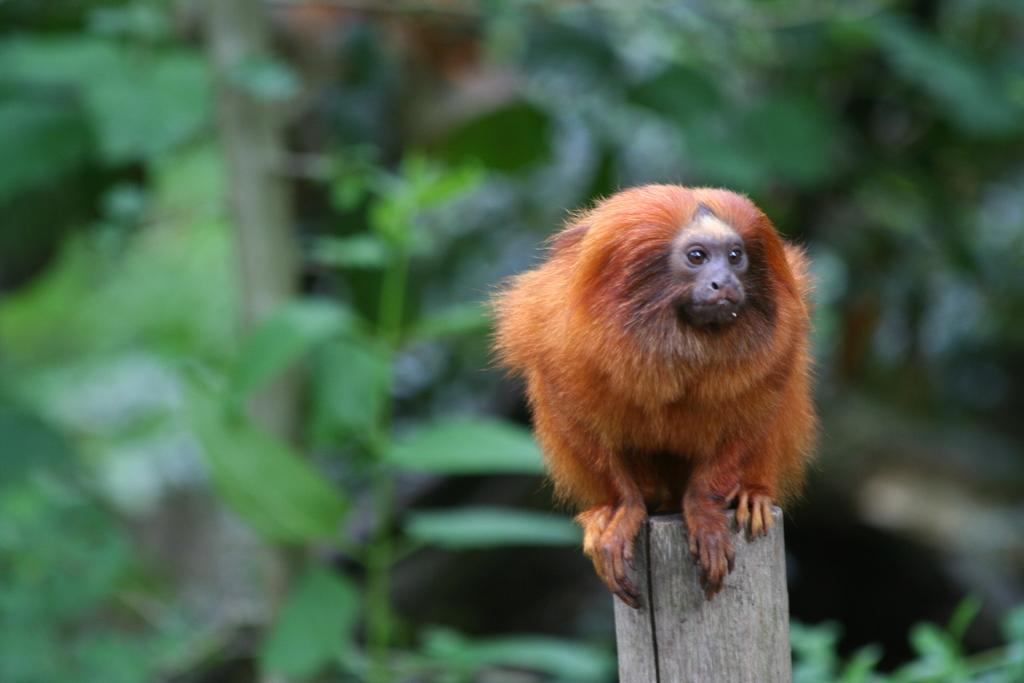What type of creature is in the image? There is an animal in the image. What color is the animal? The animal is brown in color. Where is the animal located in the image? The animal is on a wooden pole. What can be seen in the background of the image? The background of the image includes plants. What color are the plants? The plants are green in color. Can you see the seashore in the image? No, there is no seashore visible in the image. Is there a book on the wooden pole with the animal? No, there is no book present in the image. 